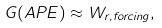<formula> <loc_0><loc_0><loc_500><loc_500>G ( A P E ) \approx W _ { r , f o r c i n g } ,</formula> 